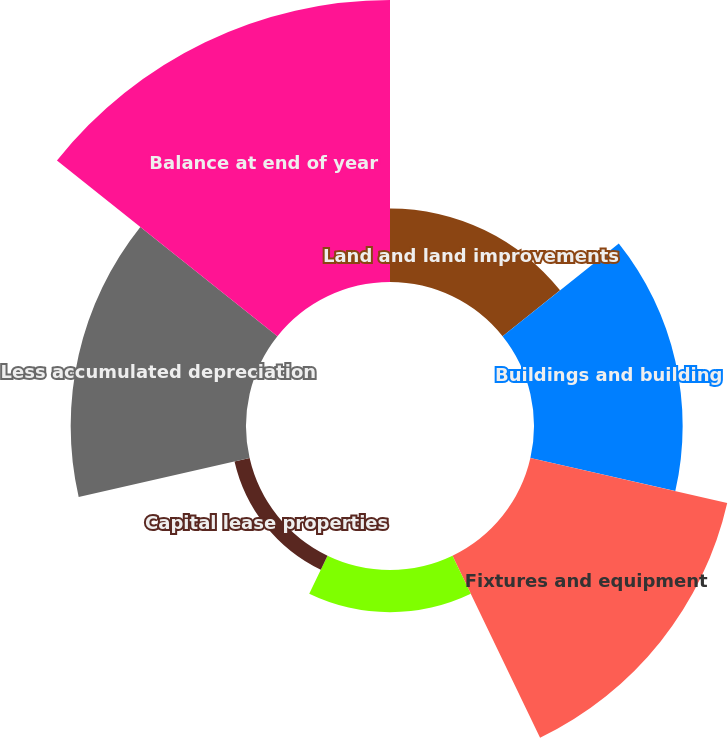Convert chart. <chart><loc_0><loc_0><loc_500><loc_500><pie_chart><fcel>Land and land improvements<fcel>Buildings and building<fcel>Fixtures and equipment<fcel>Capitalized system development<fcel>Capital lease properties<fcel>Less accumulated depreciation<fcel>Balance at end of year<nl><fcel>7.83%<fcel>15.83%<fcel>21.5%<fcel>4.49%<fcel>1.65%<fcel>18.67%<fcel>30.03%<nl></chart> 